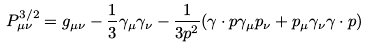Convert formula to latex. <formula><loc_0><loc_0><loc_500><loc_500>P _ { \mu \nu } ^ { 3 / 2 } = g _ { \mu \nu } - \frac { 1 } { 3 } \gamma _ { \mu } \gamma _ { \nu } - \frac { 1 } { 3 p ^ { 2 } } ( \gamma \cdot p \gamma _ { \mu } p _ { \nu } + p _ { \mu } \gamma _ { \nu } \gamma \cdot p )</formula> 